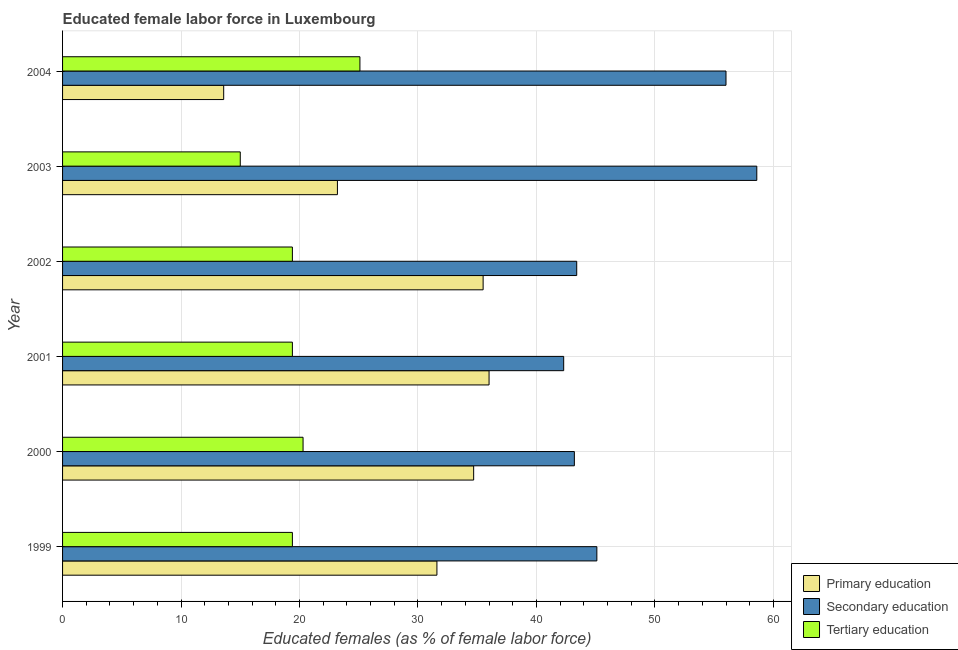How many different coloured bars are there?
Offer a very short reply. 3. How many bars are there on the 6th tick from the bottom?
Provide a short and direct response. 3. What is the percentage of female labor force who received tertiary education in 2001?
Your answer should be compact. 19.4. Across all years, what is the maximum percentage of female labor force who received secondary education?
Offer a terse response. 58.6. Across all years, what is the minimum percentage of female labor force who received primary education?
Your answer should be very brief. 13.6. In which year was the percentage of female labor force who received tertiary education minimum?
Make the answer very short. 2003. What is the total percentage of female labor force who received tertiary education in the graph?
Keep it short and to the point. 118.6. What is the difference between the percentage of female labor force who received tertiary education in 2003 and the percentage of female labor force who received secondary education in 2001?
Give a very brief answer. -27.3. What is the average percentage of female labor force who received secondary education per year?
Your answer should be compact. 48.1. In how many years, is the percentage of female labor force who received secondary education greater than 6 %?
Provide a succinct answer. 6. What is the ratio of the percentage of female labor force who received primary education in 1999 to that in 2001?
Your answer should be compact. 0.88. Is the percentage of female labor force who received tertiary education in 2002 less than that in 2003?
Provide a succinct answer. No. What is the difference between the highest and the lowest percentage of female labor force who received secondary education?
Provide a succinct answer. 16.3. Is the sum of the percentage of female labor force who received primary education in 2000 and 2003 greater than the maximum percentage of female labor force who received tertiary education across all years?
Provide a short and direct response. Yes. What does the 2nd bar from the top in 2000 represents?
Provide a succinct answer. Secondary education. What does the 3rd bar from the bottom in 2002 represents?
Your response must be concise. Tertiary education. Is it the case that in every year, the sum of the percentage of female labor force who received primary education and percentage of female labor force who received secondary education is greater than the percentage of female labor force who received tertiary education?
Your answer should be very brief. Yes. How many bars are there?
Offer a terse response. 18. Are all the bars in the graph horizontal?
Provide a short and direct response. Yes. How many years are there in the graph?
Your answer should be compact. 6. Are the values on the major ticks of X-axis written in scientific E-notation?
Provide a succinct answer. No. How are the legend labels stacked?
Keep it short and to the point. Vertical. What is the title of the graph?
Offer a terse response. Educated female labor force in Luxembourg. What is the label or title of the X-axis?
Provide a succinct answer. Educated females (as % of female labor force). What is the Educated females (as % of female labor force) in Primary education in 1999?
Provide a succinct answer. 31.6. What is the Educated females (as % of female labor force) of Secondary education in 1999?
Ensure brevity in your answer.  45.1. What is the Educated females (as % of female labor force) of Tertiary education in 1999?
Keep it short and to the point. 19.4. What is the Educated females (as % of female labor force) of Primary education in 2000?
Provide a succinct answer. 34.7. What is the Educated females (as % of female labor force) in Secondary education in 2000?
Provide a succinct answer. 43.2. What is the Educated females (as % of female labor force) of Tertiary education in 2000?
Give a very brief answer. 20.3. What is the Educated females (as % of female labor force) in Primary education in 2001?
Your response must be concise. 36. What is the Educated females (as % of female labor force) in Secondary education in 2001?
Your answer should be very brief. 42.3. What is the Educated females (as % of female labor force) in Tertiary education in 2001?
Make the answer very short. 19.4. What is the Educated females (as % of female labor force) of Primary education in 2002?
Offer a very short reply. 35.5. What is the Educated females (as % of female labor force) of Secondary education in 2002?
Your answer should be very brief. 43.4. What is the Educated females (as % of female labor force) in Tertiary education in 2002?
Make the answer very short. 19.4. What is the Educated females (as % of female labor force) in Primary education in 2003?
Ensure brevity in your answer.  23.2. What is the Educated females (as % of female labor force) in Secondary education in 2003?
Offer a very short reply. 58.6. What is the Educated females (as % of female labor force) in Tertiary education in 2003?
Provide a short and direct response. 15. What is the Educated females (as % of female labor force) of Primary education in 2004?
Provide a succinct answer. 13.6. What is the Educated females (as % of female labor force) in Tertiary education in 2004?
Your response must be concise. 25.1. Across all years, what is the maximum Educated females (as % of female labor force) in Secondary education?
Make the answer very short. 58.6. Across all years, what is the maximum Educated females (as % of female labor force) in Tertiary education?
Offer a terse response. 25.1. Across all years, what is the minimum Educated females (as % of female labor force) of Primary education?
Offer a very short reply. 13.6. Across all years, what is the minimum Educated females (as % of female labor force) of Secondary education?
Make the answer very short. 42.3. What is the total Educated females (as % of female labor force) in Primary education in the graph?
Offer a terse response. 174.6. What is the total Educated females (as % of female labor force) of Secondary education in the graph?
Give a very brief answer. 288.6. What is the total Educated females (as % of female labor force) in Tertiary education in the graph?
Your response must be concise. 118.6. What is the difference between the Educated females (as % of female labor force) of Primary education in 1999 and that in 2000?
Make the answer very short. -3.1. What is the difference between the Educated females (as % of female labor force) in Tertiary education in 1999 and that in 2000?
Make the answer very short. -0.9. What is the difference between the Educated females (as % of female labor force) of Primary education in 1999 and that in 2001?
Make the answer very short. -4.4. What is the difference between the Educated females (as % of female labor force) of Secondary education in 1999 and that in 2001?
Make the answer very short. 2.8. What is the difference between the Educated females (as % of female labor force) of Tertiary education in 1999 and that in 2001?
Make the answer very short. 0. What is the difference between the Educated females (as % of female labor force) in Primary education in 1999 and that in 2002?
Your answer should be very brief. -3.9. What is the difference between the Educated females (as % of female labor force) in Secondary education in 1999 and that in 2002?
Give a very brief answer. 1.7. What is the difference between the Educated females (as % of female labor force) in Tertiary education in 1999 and that in 2002?
Your answer should be very brief. 0. What is the difference between the Educated females (as % of female labor force) of Primary education in 1999 and that in 2003?
Offer a terse response. 8.4. What is the difference between the Educated females (as % of female labor force) of Secondary education in 1999 and that in 2003?
Provide a short and direct response. -13.5. What is the difference between the Educated females (as % of female labor force) of Primary education in 1999 and that in 2004?
Your answer should be compact. 18. What is the difference between the Educated females (as % of female labor force) of Secondary education in 1999 and that in 2004?
Your answer should be very brief. -10.9. What is the difference between the Educated females (as % of female labor force) in Tertiary education in 1999 and that in 2004?
Keep it short and to the point. -5.7. What is the difference between the Educated females (as % of female labor force) in Primary education in 2000 and that in 2003?
Provide a short and direct response. 11.5. What is the difference between the Educated females (as % of female labor force) in Secondary education in 2000 and that in 2003?
Ensure brevity in your answer.  -15.4. What is the difference between the Educated females (as % of female labor force) of Primary education in 2000 and that in 2004?
Give a very brief answer. 21.1. What is the difference between the Educated females (as % of female labor force) in Tertiary education in 2000 and that in 2004?
Make the answer very short. -4.8. What is the difference between the Educated females (as % of female labor force) in Secondary education in 2001 and that in 2002?
Your answer should be compact. -1.1. What is the difference between the Educated females (as % of female labor force) of Secondary education in 2001 and that in 2003?
Provide a succinct answer. -16.3. What is the difference between the Educated females (as % of female labor force) in Tertiary education in 2001 and that in 2003?
Ensure brevity in your answer.  4.4. What is the difference between the Educated females (as % of female labor force) in Primary education in 2001 and that in 2004?
Offer a very short reply. 22.4. What is the difference between the Educated females (as % of female labor force) of Secondary education in 2001 and that in 2004?
Provide a succinct answer. -13.7. What is the difference between the Educated females (as % of female labor force) of Primary education in 2002 and that in 2003?
Offer a terse response. 12.3. What is the difference between the Educated females (as % of female labor force) in Secondary education in 2002 and that in 2003?
Offer a very short reply. -15.2. What is the difference between the Educated females (as % of female labor force) of Primary education in 2002 and that in 2004?
Offer a terse response. 21.9. What is the difference between the Educated females (as % of female labor force) of Secondary education in 2002 and that in 2004?
Keep it short and to the point. -12.6. What is the difference between the Educated females (as % of female labor force) in Tertiary education in 2002 and that in 2004?
Provide a succinct answer. -5.7. What is the difference between the Educated females (as % of female labor force) in Primary education in 2003 and that in 2004?
Your answer should be very brief. 9.6. What is the difference between the Educated females (as % of female labor force) in Tertiary education in 2003 and that in 2004?
Make the answer very short. -10.1. What is the difference between the Educated females (as % of female labor force) of Primary education in 1999 and the Educated females (as % of female labor force) of Tertiary education in 2000?
Offer a terse response. 11.3. What is the difference between the Educated females (as % of female labor force) in Secondary education in 1999 and the Educated females (as % of female labor force) in Tertiary education in 2000?
Offer a very short reply. 24.8. What is the difference between the Educated females (as % of female labor force) in Primary education in 1999 and the Educated females (as % of female labor force) in Secondary education in 2001?
Offer a very short reply. -10.7. What is the difference between the Educated females (as % of female labor force) of Primary education in 1999 and the Educated females (as % of female labor force) of Tertiary education in 2001?
Make the answer very short. 12.2. What is the difference between the Educated females (as % of female labor force) in Secondary education in 1999 and the Educated females (as % of female labor force) in Tertiary education in 2001?
Ensure brevity in your answer.  25.7. What is the difference between the Educated females (as % of female labor force) of Primary education in 1999 and the Educated females (as % of female labor force) of Secondary education in 2002?
Offer a terse response. -11.8. What is the difference between the Educated females (as % of female labor force) of Primary education in 1999 and the Educated females (as % of female labor force) of Tertiary education in 2002?
Your response must be concise. 12.2. What is the difference between the Educated females (as % of female labor force) of Secondary education in 1999 and the Educated females (as % of female labor force) of Tertiary education in 2002?
Offer a terse response. 25.7. What is the difference between the Educated females (as % of female labor force) in Primary education in 1999 and the Educated females (as % of female labor force) in Secondary education in 2003?
Ensure brevity in your answer.  -27. What is the difference between the Educated females (as % of female labor force) in Secondary education in 1999 and the Educated females (as % of female labor force) in Tertiary education in 2003?
Ensure brevity in your answer.  30.1. What is the difference between the Educated females (as % of female labor force) of Primary education in 1999 and the Educated females (as % of female labor force) of Secondary education in 2004?
Ensure brevity in your answer.  -24.4. What is the difference between the Educated females (as % of female labor force) of Secondary education in 1999 and the Educated females (as % of female labor force) of Tertiary education in 2004?
Ensure brevity in your answer.  20. What is the difference between the Educated females (as % of female labor force) of Secondary education in 2000 and the Educated females (as % of female labor force) of Tertiary education in 2001?
Make the answer very short. 23.8. What is the difference between the Educated females (as % of female labor force) in Secondary education in 2000 and the Educated females (as % of female labor force) in Tertiary education in 2002?
Provide a succinct answer. 23.8. What is the difference between the Educated females (as % of female labor force) of Primary education in 2000 and the Educated females (as % of female labor force) of Secondary education in 2003?
Offer a very short reply. -23.9. What is the difference between the Educated females (as % of female labor force) of Secondary education in 2000 and the Educated females (as % of female labor force) of Tertiary education in 2003?
Provide a short and direct response. 28.2. What is the difference between the Educated females (as % of female labor force) in Primary education in 2000 and the Educated females (as % of female labor force) in Secondary education in 2004?
Give a very brief answer. -21.3. What is the difference between the Educated females (as % of female labor force) in Primary education in 2000 and the Educated females (as % of female labor force) in Tertiary education in 2004?
Ensure brevity in your answer.  9.6. What is the difference between the Educated females (as % of female labor force) in Secondary education in 2000 and the Educated females (as % of female labor force) in Tertiary education in 2004?
Provide a succinct answer. 18.1. What is the difference between the Educated females (as % of female labor force) of Primary education in 2001 and the Educated females (as % of female labor force) of Secondary education in 2002?
Make the answer very short. -7.4. What is the difference between the Educated females (as % of female labor force) of Primary education in 2001 and the Educated females (as % of female labor force) of Tertiary education in 2002?
Make the answer very short. 16.6. What is the difference between the Educated females (as % of female labor force) in Secondary education in 2001 and the Educated females (as % of female labor force) in Tertiary education in 2002?
Your answer should be very brief. 22.9. What is the difference between the Educated females (as % of female labor force) of Primary education in 2001 and the Educated females (as % of female labor force) of Secondary education in 2003?
Your answer should be very brief. -22.6. What is the difference between the Educated females (as % of female labor force) in Secondary education in 2001 and the Educated females (as % of female labor force) in Tertiary education in 2003?
Your answer should be very brief. 27.3. What is the difference between the Educated females (as % of female labor force) of Primary education in 2001 and the Educated females (as % of female labor force) of Secondary education in 2004?
Provide a short and direct response. -20. What is the difference between the Educated females (as % of female labor force) in Primary education in 2001 and the Educated females (as % of female labor force) in Tertiary education in 2004?
Keep it short and to the point. 10.9. What is the difference between the Educated females (as % of female labor force) of Primary education in 2002 and the Educated females (as % of female labor force) of Secondary education in 2003?
Offer a terse response. -23.1. What is the difference between the Educated females (as % of female labor force) of Primary education in 2002 and the Educated females (as % of female labor force) of Tertiary education in 2003?
Your answer should be very brief. 20.5. What is the difference between the Educated females (as % of female labor force) in Secondary education in 2002 and the Educated females (as % of female labor force) in Tertiary education in 2003?
Provide a short and direct response. 28.4. What is the difference between the Educated females (as % of female labor force) of Primary education in 2002 and the Educated females (as % of female labor force) of Secondary education in 2004?
Provide a short and direct response. -20.5. What is the difference between the Educated females (as % of female labor force) in Primary education in 2003 and the Educated females (as % of female labor force) in Secondary education in 2004?
Offer a very short reply. -32.8. What is the difference between the Educated females (as % of female labor force) in Secondary education in 2003 and the Educated females (as % of female labor force) in Tertiary education in 2004?
Provide a short and direct response. 33.5. What is the average Educated females (as % of female labor force) in Primary education per year?
Your answer should be compact. 29.1. What is the average Educated females (as % of female labor force) in Secondary education per year?
Give a very brief answer. 48.1. What is the average Educated females (as % of female labor force) of Tertiary education per year?
Offer a very short reply. 19.77. In the year 1999, what is the difference between the Educated females (as % of female labor force) in Primary education and Educated females (as % of female labor force) in Tertiary education?
Your response must be concise. 12.2. In the year 1999, what is the difference between the Educated females (as % of female labor force) in Secondary education and Educated females (as % of female labor force) in Tertiary education?
Your answer should be compact. 25.7. In the year 2000, what is the difference between the Educated females (as % of female labor force) of Primary education and Educated females (as % of female labor force) of Secondary education?
Your answer should be compact. -8.5. In the year 2000, what is the difference between the Educated females (as % of female labor force) in Primary education and Educated females (as % of female labor force) in Tertiary education?
Your answer should be very brief. 14.4. In the year 2000, what is the difference between the Educated females (as % of female labor force) in Secondary education and Educated females (as % of female labor force) in Tertiary education?
Ensure brevity in your answer.  22.9. In the year 2001, what is the difference between the Educated females (as % of female labor force) of Secondary education and Educated females (as % of female labor force) of Tertiary education?
Provide a succinct answer. 22.9. In the year 2002, what is the difference between the Educated females (as % of female labor force) in Primary education and Educated females (as % of female labor force) in Secondary education?
Keep it short and to the point. -7.9. In the year 2003, what is the difference between the Educated females (as % of female labor force) in Primary education and Educated females (as % of female labor force) in Secondary education?
Keep it short and to the point. -35.4. In the year 2003, what is the difference between the Educated females (as % of female labor force) of Secondary education and Educated females (as % of female labor force) of Tertiary education?
Offer a very short reply. 43.6. In the year 2004, what is the difference between the Educated females (as % of female labor force) in Primary education and Educated females (as % of female labor force) in Secondary education?
Keep it short and to the point. -42.4. In the year 2004, what is the difference between the Educated females (as % of female labor force) in Primary education and Educated females (as % of female labor force) in Tertiary education?
Keep it short and to the point. -11.5. In the year 2004, what is the difference between the Educated females (as % of female labor force) of Secondary education and Educated females (as % of female labor force) of Tertiary education?
Keep it short and to the point. 30.9. What is the ratio of the Educated females (as % of female labor force) of Primary education in 1999 to that in 2000?
Offer a very short reply. 0.91. What is the ratio of the Educated females (as % of female labor force) in Secondary education in 1999 to that in 2000?
Provide a short and direct response. 1.04. What is the ratio of the Educated females (as % of female labor force) in Tertiary education in 1999 to that in 2000?
Offer a terse response. 0.96. What is the ratio of the Educated females (as % of female labor force) of Primary education in 1999 to that in 2001?
Give a very brief answer. 0.88. What is the ratio of the Educated females (as % of female labor force) of Secondary education in 1999 to that in 2001?
Offer a very short reply. 1.07. What is the ratio of the Educated females (as % of female labor force) of Tertiary education in 1999 to that in 2001?
Provide a succinct answer. 1. What is the ratio of the Educated females (as % of female labor force) of Primary education in 1999 to that in 2002?
Your answer should be very brief. 0.89. What is the ratio of the Educated females (as % of female labor force) in Secondary education in 1999 to that in 2002?
Offer a terse response. 1.04. What is the ratio of the Educated females (as % of female labor force) in Primary education in 1999 to that in 2003?
Provide a succinct answer. 1.36. What is the ratio of the Educated females (as % of female labor force) in Secondary education in 1999 to that in 2003?
Keep it short and to the point. 0.77. What is the ratio of the Educated females (as % of female labor force) in Tertiary education in 1999 to that in 2003?
Provide a succinct answer. 1.29. What is the ratio of the Educated females (as % of female labor force) of Primary education in 1999 to that in 2004?
Give a very brief answer. 2.32. What is the ratio of the Educated females (as % of female labor force) of Secondary education in 1999 to that in 2004?
Keep it short and to the point. 0.81. What is the ratio of the Educated females (as % of female labor force) in Tertiary education in 1999 to that in 2004?
Offer a terse response. 0.77. What is the ratio of the Educated females (as % of female labor force) in Primary education in 2000 to that in 2001?
Keep it short and to the point. 0.96. What is the ratio of the Educated females (as % of female labor force) of Secondary education in 2000 to that in 2001?
Your response must be concise. 1.02. What is the ratio of the Educated females (as % of female labor force) of Tertiary education in 2000 to that in 2001?
Your answer should be very brief. 1.05. What is the ratio of the Educated females (as % of female labor force) in Primary education in 2000 to that in 2002?
Offer a very short reply. 0.98. What is the ratio of the Educated females (as % of female labor force) of Secondary education in 2000 to that in 2002?
Provide a succinct answer. 1. What is the ratio of the Educated females (as % of female labor force) in Tertiary education in 2000 to that in 2002?
Ensure brevity in your answer.  1.05. What is the ratio of the Educated females (as % of female labor force) in Primary education in 2000 to that in 2003?
Provide a succinct answer. 1.5. What is the ratio of the Educated females (as % of female labor force) of Secondary education in 2000 to that in 2003?
Give a very brief answer. 0.74. What is the ratio of the Educated females (as % of female labor force) of Tertiary education in 2000 to that in 2003?
Keep it short and to the point. 1.35. What is the ratio of the Educated females (as % of female labor force) of Primary education in 2000 to that in 2004?
Offer a terse response. 2.55. What is the ratio of the Educated females (as % of female labor force) in Secondary education in 2000 to that in 2004?
Give a very brief answer. 0.77. What is the ratio of the Educated females (as % of female labor force) in Tertiary education in 2000 to that in 2004?
Make the answer very short. 0.81. What is the ratio of the Educated females (as % of female labor force) in Primary education in 2001 to that in 2002?
Your answer should be very brief. 1.01. What is the ratio of the Educated females (as % of female labor force) in Secondary education in 2001 to that in 2002?
Your answer should be very brief. 0.97. What is the ratio of the Educated females (as % of female labor force) of Tertiary education in 2001 to that in 2002?
Give a very brief answer. 1. What is the ratio of the Educated females (as % of female labor force) in Primary education in 2001 to that in 2003?
Provide a succinct answer. 1.55. What is the ratio of the Educated females (as % of female labor force) in Secondary education in 2001 to that in 2003?
Keep it short and to the point. 0.72. What is the ratio of the Educated females (as % of female labor force) in Tertiary education in 2001 to that in 2003?
Offer a very short reply. 1.29. What is the ratio of the Educated females (as % of female labor force) in Primary education in 2001 to that in 2004?
Your answer should be very brief. 2.65. What is the ratio of the Educated females (as % of female labor force) of Secondary education in 2001 to that in 2004?
Provide a succinct answer. 0.76. What is the ratio of the Educated females (as % of female labor force) of Tertiary education in 2001 to that in 2004?
Your answer should be very brief. 0.77. What is the ratio of the Educated females (as % of female labor force) of Primary education in 2002 to that in 2003?
Offer a very short reply. 1.53. What is the ratio of the Educated females (as % of female labor force) in Secondary education in 2002 to that in 2003?
Provide a succinct answer. 0.74. What is the ratio of the Educated females (as % of female labor force) in Tertiary education in 2002 to that in 2003?
Offer a very short reply. 1.29. What is the ratio of the Educated females (as % of female labor force) of Primary education in 2002 to that in 2004?
Make the answer very short. 2.61. What is the ratio of the Educated females (as % of female labor force) of Secondary education in 2002 to that in 2004?
Your answer should be very brief. 0.78. What is the ratio of the Educated females (as % of female labor force) in Tertiary education in 2002 to that in 2004?
Provide a succinct answer. 0.77. What is the ratio of the Educated females (as % of female labor force) of Primary education in 2003 to that in 2004?
Ensure brevity in your answer.  1.71. What is the ratio of the Educated females (as % of female labor force) in Secondary education in 2003 to that in 2004?
Your answer should be compact. 1.05. What is the ratio of the Educated females (as % of female labor force) in Tertiary education in 2003 to that in 2004?
Offer a very short reply. 0.6. What is the difference between the highest and the second highest Educated females (as % of female labor force) of Primary education?
Offer a terse response. 0.5. What is the difference between the highest and the second highest Educated females (as % of female labor force) of Tertiary education?
Offer a terse response. 4.8. What is the difference between the highest and the lowest Educated females (as % of female labor force) of Primary education?
Provide a short and direct response. 22.4. What is the difference between the highest and the lowest Educated females (as % of female labor force) in Secondary education?
Provide a succinct answer. 16.3. 